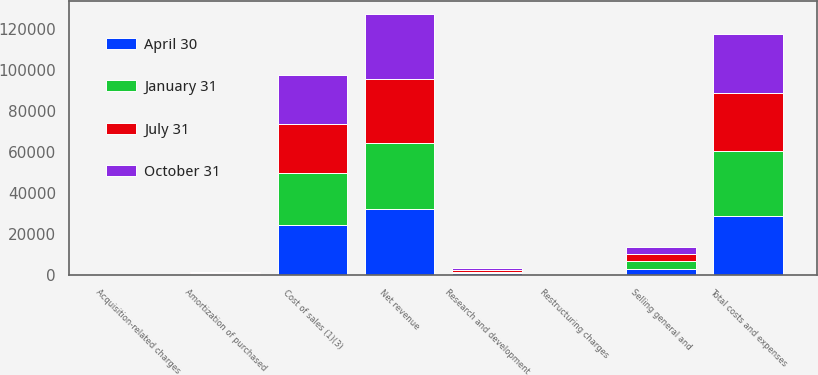Convert chart. <chart><loc_0><loc_0><loc_500><loc_500><stacked_bar_chart><ecel><fcel>Net revenue<fcel>Cost of sales (1)(3)<fcel>Research and development<fcel>Selling general and<fcel>Amortization of purchased<fcel>Restructuring charges<fcel>Acquisition-related charges<fcel>Total costs and expenses<nl><fcel>April 30<fcel>32302<fcel>24381<fcel>798<fcel>3117<fcel>425<fcel>158<fcel>29<fcel>28908<nl><fcel>October 31<fcel>31632<fcel>23832<fcel>815<fcel>3425<fcel>413<fcel>158<fcel>21<fcel>28664<nl><fcel>July 31<fcel>31189<fcel>23901<fcel>812<fcel>3430<fcel>358<fcel>150<fcel>18<fcel>28669<nl><fcel>January 31<fcel>32122<fcel>25304<fcel>829<fcel>3605<fcel>411<fcel>179<fcel>114<fcel>31327<nl></chart> 